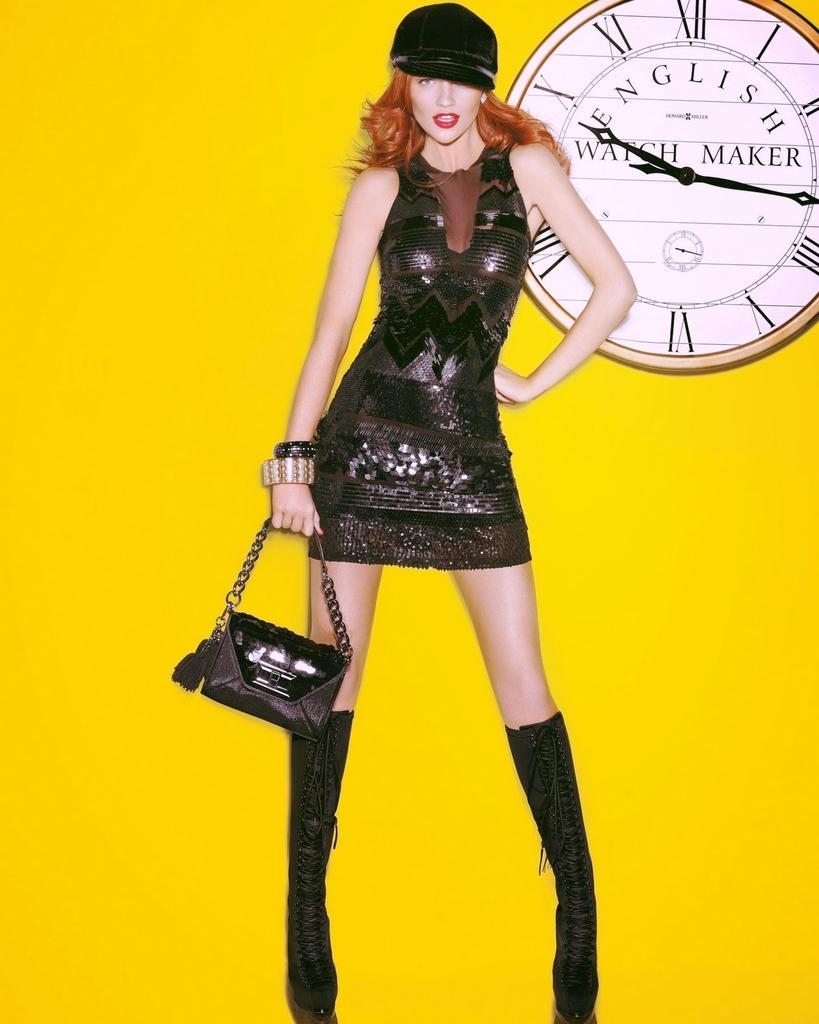Describe this image in one or two sentences. On the background we can see yellow color wall and a clock. Here we can see one women wearing a black dress and a black hat and she is holding a black hand bag in her hand. 